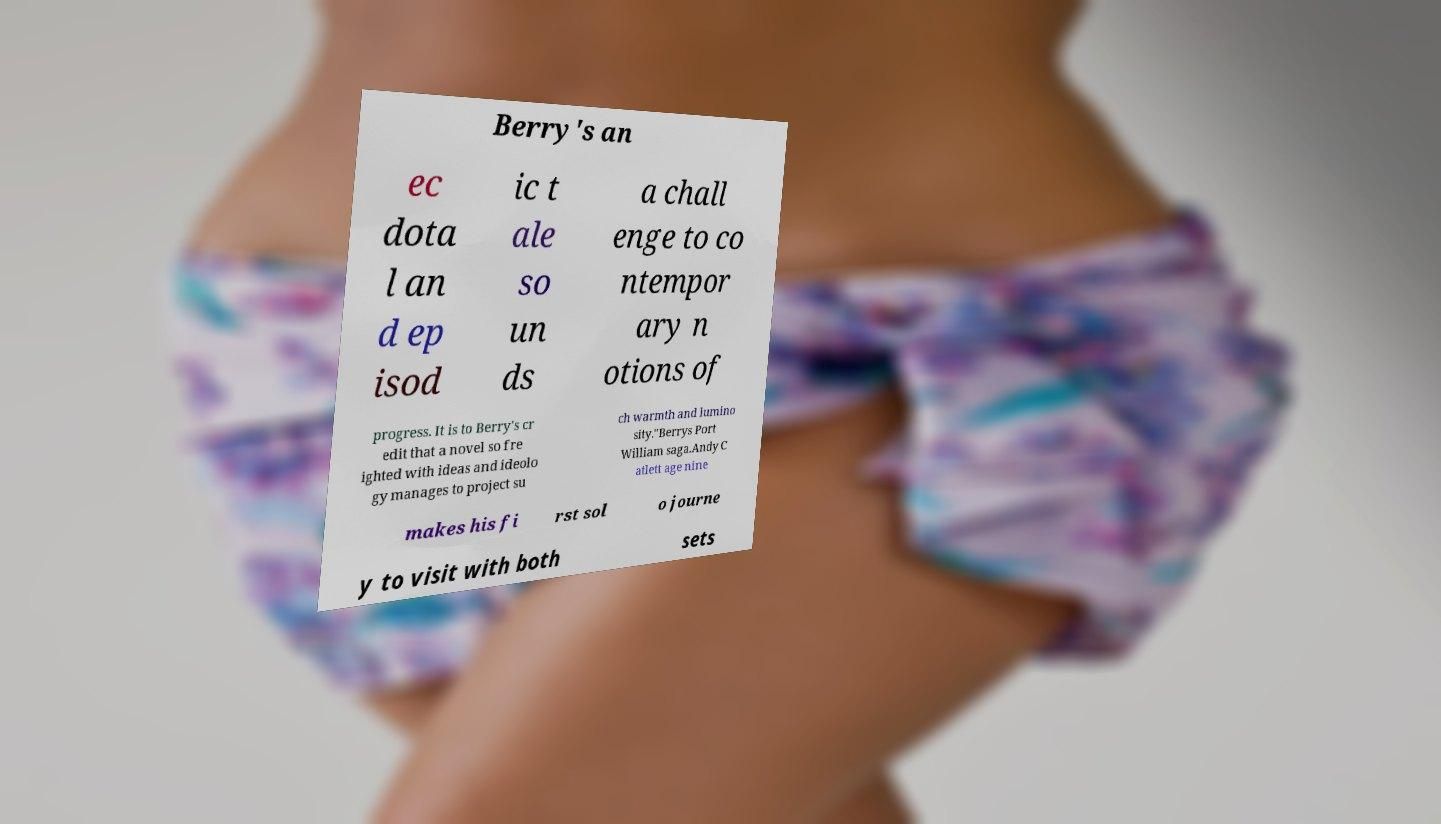For documentation purposes, I need the text within this image transcribed. Could you provide that? Berry's an ec dota l an d ep isod ic t ale so un ds a chall enge to co ntempor ary n otions of progress. It is to Berry's cr edit that a novel so fre ighted with ideas and ideolo gy manages to project su ch warmth and lumino sity."Berrys Port William saga.Andy C atlett age nine makes his fi rst sol o journe y to visit with both sets 